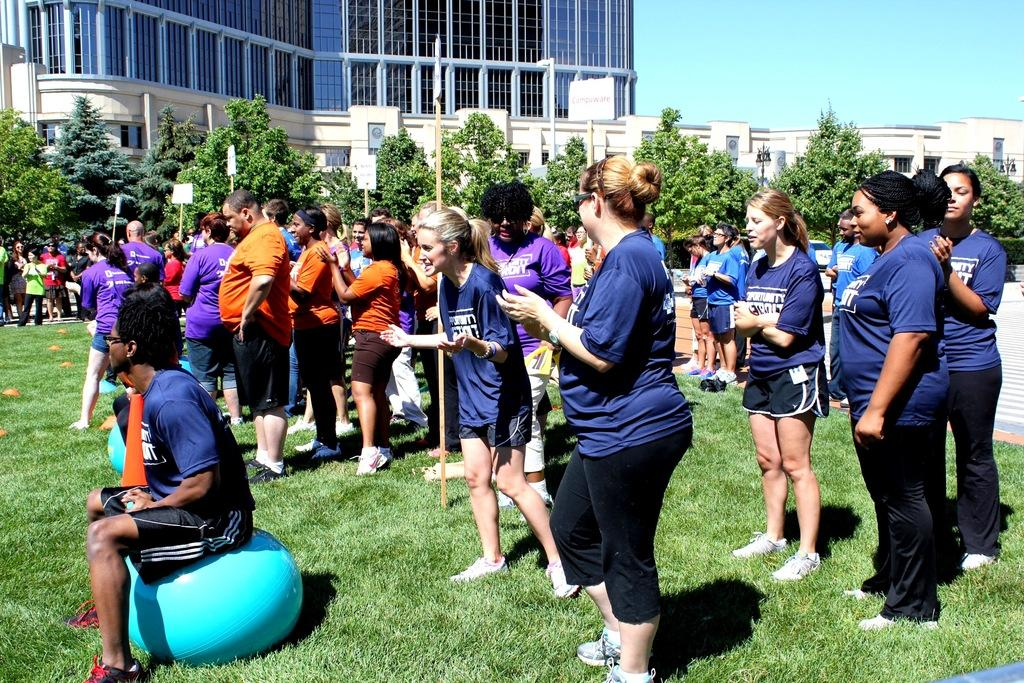What are the people in the image standing on? The people in the image are standing on the ground. What type of vegetation is present on the ground? There is grass on the ground. What can be seen in the background of the image? There are trees visible and buildings in the background. What part of the natural environment is visible in the image? The sky is visible in the image. What type of iron is being used for the discussion in the image? There is no iron or discussion present in the image. 